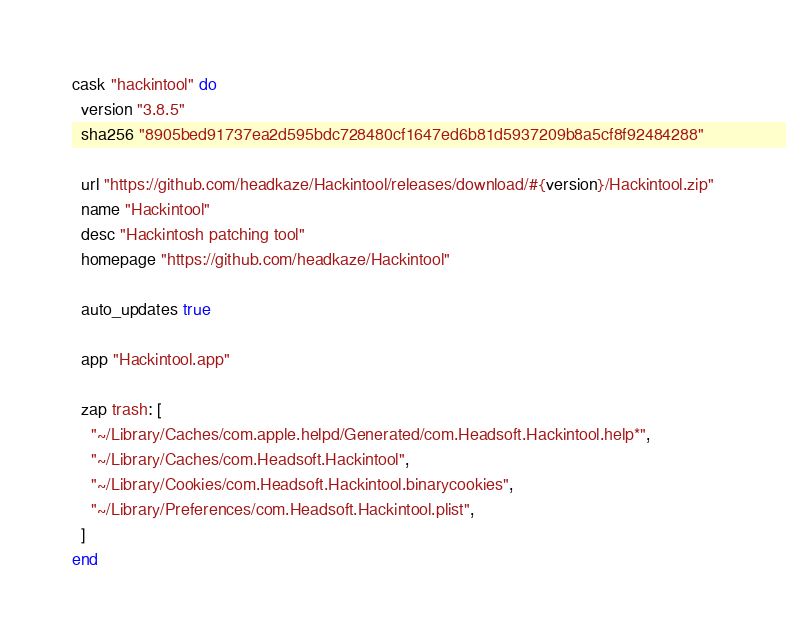<code> <loc_0><loc_0><loc_500><loc_500><_Ruby_>cask "hackintool" do
  version "3.8.5"
  sha256 "8905bed91737ea2d595bdc728480cf1647ed6b81d5937209b8a5cf8f92484288"

  url "https://github.com/headkaze/Hackintool/releases/download/#{version}/Hackintool.zip"
  name "Hackintool"
  desc "Hackintosh patching tool"
  homepage "https://github.com/headkaze/Hackintool"

  auto_updates true

  app "Hackintool.app"

  zap trash: [
    "~/Library/Caches/com.apple.helpd/Generated/com.Headsoft.Hackintool.help*",
    "~/Library/Caches/com.Headsoft.Hackintool",
    "~/Library/Cookies/com.Headsoft.Hackintool.binarycookies",
    "~/Library/Preferences/com.Headsoft.Hackintool.plist",
  ]
end
</code> 